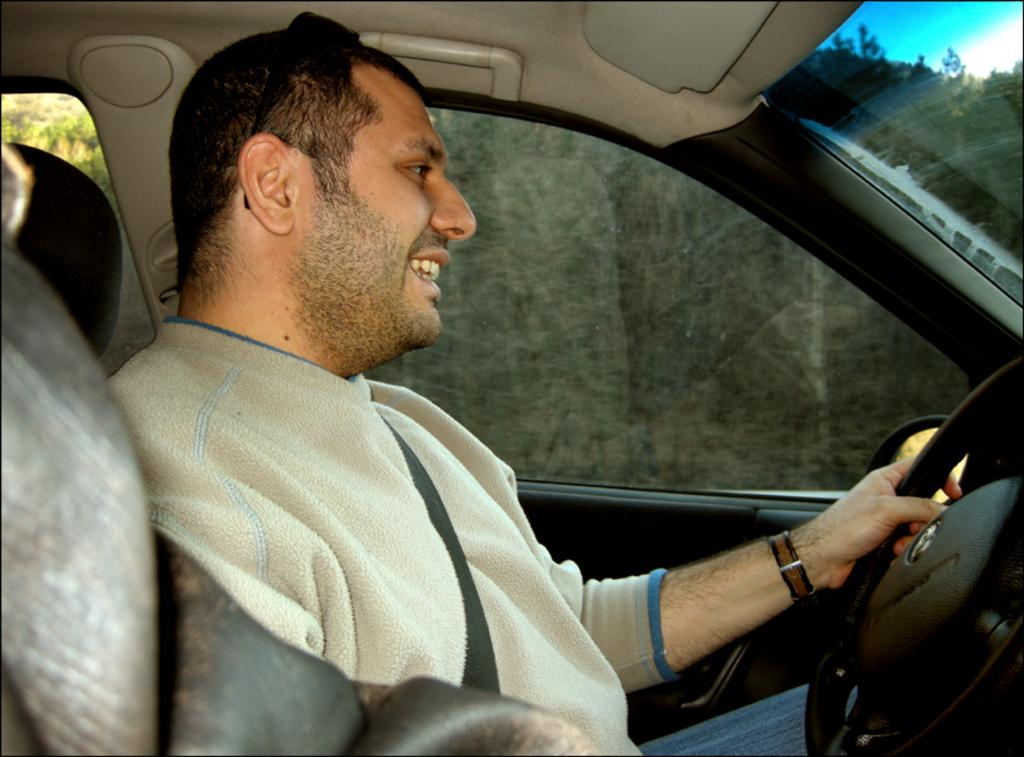What is the main subject of the image? The main subject of the image is a man. What is the man doing in the image? The man is seated in the image. What is the man's facial expression in the image? The man is smiling in the image. Where is the man located in the image? The man is in a car in the image. What type of kettle can be seen in the image? There is no kettle present in the image. What is the man using to hold his arrows in the image? There are no arrows or quiver present in the image. 